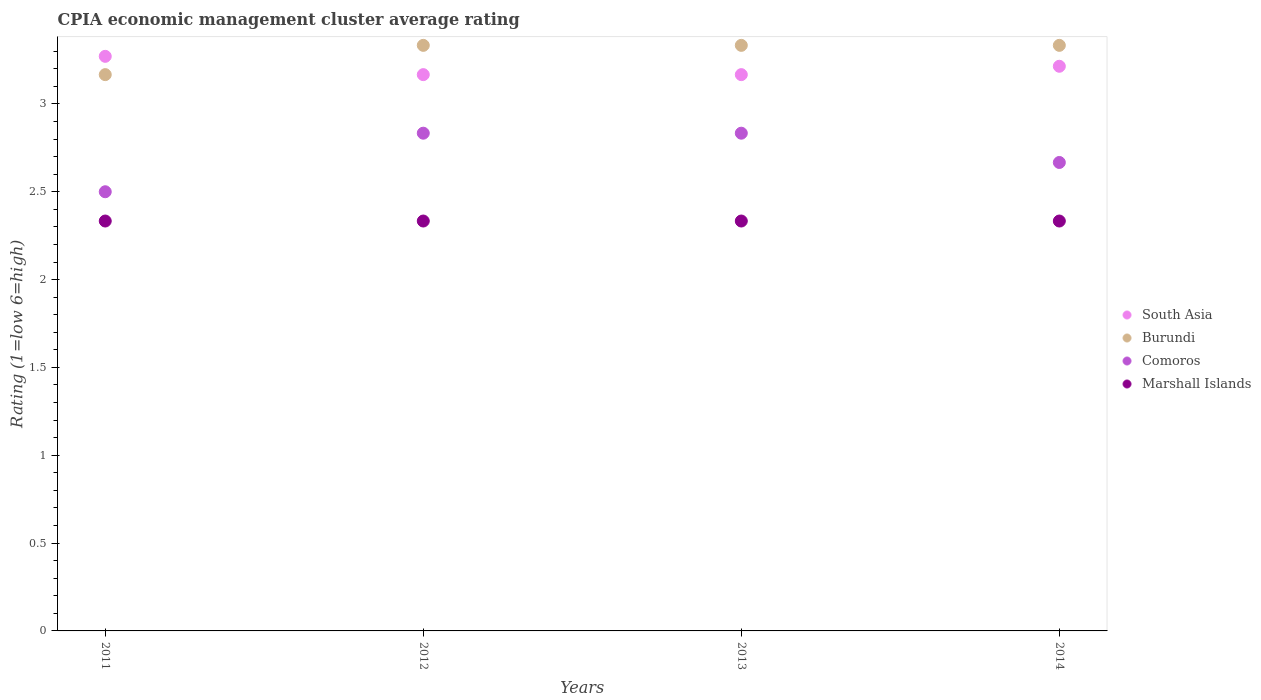Is the number of dotlines equal to the number of legend labels?
Give a very brief answer. Yes. What is the CPIA rating in Comoros in 2011?
Make the answer very short. 2.5. Across all years, what is the maximum CPIA rating in Burundi?
Give a very brief answer. 3.33. Across all years, what is the minimum CPIA rating in Burundi?
Provide a succinct answer. 3.17. In which year was the CPIA rating in Burundi maximum?
Your answer should be compact. 2012. What is the total CPIA rating in Comoros in the graph?
Your answer should be very brief. 10.83. What is the difference between the CPIA rating in Comoros in 2013 and that in 2014?
Ensure brevity in your answer.  0.17. What is the difference between the CPIA rating in Comoros in 2011 and the CPIA rating in Marshall Islands in 2013?
Keep it short and to the point. 0.17. What is the average CPIA rating in Marshall Islands per year?
Your response must be concise. 2.33. In how many years, is the CPIA rating in South Asia greater than 1.3?
Offer a terse response. 4. What is the ratio of the CPIA rating in Marshall Islands in 2012 to that in 2014?
Your answer should be compact. 1. Is the CPIA rating in South Asia in 2012 less than that in 2014?
Ensure brevity in your answer.  Yes. Is the difference between the CPIA rating in Burundi in 2011 and 2014 greater than the difference between the CPIA rating in Comoros in 2011 and 2014?
Give a very brief answer. Yes. What is the difference between the highest and the lowest CPIA rating in South Asia?
Ensure brevity in your answer.  0.1. Is the sum of the CPIA rating in Burundi in 2011 and 2013 greater than the maximum CPIA rating in Marshall Islands across all years?
Provide a succinct answer. Yes. Is it the case that in every year, the sum of the CPIA rating in Burundi and CPIA rating in Comoros  is greater than the sum of CPIA rating in Marshall Islands and CPIA rating in South Asia?
Make the answer very short. Yes. Does the CPIA rating in South Asia monotonically increase over the years?
Your response must be concise. No. How many dotlines are there?
Your response must be concise. 4. Are the values on the major ticks of Y-axis written in scientific E-notation?
Ensure brevity in your answer.  No. Does the graph contain any zero values?
Your response must be concise. No. Does the graph contain grids?
Keep it short and to the point. No. Where does the legend appear in the graph?
Your response must be concise. Center right. How are the legend labels stacked?
Your answer should be compact. Vertical. What is the title of the graph?
Your answer should be very brief. CPIA economic management cluster average rating. What is the label or title of the Y-axis?
Offer a terse response. Rating (1=low 6=high). What is the Rating (1=low 6=high) of South Asia in 2011?
Your answer should be very brief. 3.27. What is the Rating (1=low 6=high) in Burundi in 2011?
Your answer should be very brief. 3.17. What is the Rating (1=low 6=high) of Comoros in 2011?
Give a very brief answer. 2.5. What is the Rating (1=low 6=high) of Marshall Islands in 2011?
Provide a succinct answer. 2.33. What is the Rating (1=low 6=high) in South Asia in 2012?
Give a very brief answer. 3.17. What is the Rating (1=low 6=high) of Burundi in 2012?
Make the answer very short. 3.33. What is the Rating (1=low 6=high) in Comoros in 2012?
Your answer should be compact. 2.83. What is the Rating (1=low 6=high) in Marshall Islands in 2012?
Offer a terse response. 2.33. What is the Rating (1=low 6=high) in South Asia in 2013?
Your response must be concise. 3.17. What is the Rating (1=low 6=high) of Burundi in 2013?
Offer a terse response. 3.33. What is the Rating (1=low 6=high) of Comoros in 2013?
Ensure brevity in your answer.  2.83. What is the Rating (1=low 6=high) of Marshall Islands in 2013?
Offer a terse response. 2.33. What is the Rating (1=low 6=high) in South Asia in 2014?
Offer a terse response. 3.21. What is the Rating (1=low 6=high) of Burundi in 2014?
Ensure brevity in your answer.  3.33. What is the Rating (1=low 6=high) of Comoros in 2014?
Offer a terse response. 2.67. What is the Rating (1=low 6=high) of Marshall Islands in 2014?
Ensure brevity in your answer.  2.33. Across all years, what is the maximum Rating (1=low 6=high) in South Asia?
Provide a short and direct response. 3.27. Across all years, what is the maximum Rating (1=low 6=high) of Burundi?
Make the answer very short. 3.33. Across all years, what is the maximum Rating (1=low 6=high) of Comoros?
Offer a terse response. 2.83. Across all years, what is the maximum Rating (1=low 6=high) of Marshall Islands?
Keep it short and to the point. 2.33. Across all years, what is the minimum Rating (1=low 6=high) in South Asia?
Your response must be concise. 3.17. Across all years, what is the minimum Rating (1=low 6=high) in Burundi?
Make the answer very short. 3.17. Across all years, what is the minimum Rating (1=low 6=high) of Marshall Islands?
Provide a short and direct response. 2.33. What is the total Rating (1=low 6=high) in South Asia in the graph?
Your response must be concise. 12.82. What is the total Rating (1=low 6=high) of Burundi in the graph?
Offer a very short reply. 13.17. What is the total Rating (1=low 6=high) of Comoros in the graph?
Your answer should be very brief. 10.83. What is the total Rating (1=low 6=high) in Marshall Islands in the graph?
Make the answer very short. 9.33. What is the difference between the Rating (1=low 6=high) in South Asia in 2011 and that in 2012?
Provide a succinct answer. 0.1. What is the difference between the Rating (1=low 6=high) of Burundi in 2011 and that in 2012?
Provide a succinct answer. -0.17. What is the difference between the Rating (1=low 6=high) of Comoros in 2011 and that in 2012?
Your answer should be compact. -0.33. What is the difference between the Rating (1=low 6=high) in South Asia in 2011 and that in 2013?
Give a very brief answer. 0.1. What is the difference between the Rating (1=low 6=high) of Marshall Islands in 2011 and that in 2013?
Provide a succinct answer. 0. What is the difference between the Rating (1=low 6=high) of South Asia in 2011 and that in 2014?
Your answer should be very brief. 0.06. What is the difference between the Rating (1=low 6=high) of Comoros in 2012 and that in 2013?
Offer a very short reply. 0. What is the difference between the Rating (1=low 6=high) of Marshall Islands in 2012 and that in 2013?
Keep it short and to the point. 0. What is the difference between the Rating (1=low 6=high) of South Asia in 2012 and that in 2014?
Provide a succinct answer. -0.05. What is the difference between the Rating (1=low 6=high) in Comoros in 2012 and that in 2014?
Offer a terse response. 0.17. What is the difference between the Rating (1=low 6=high) in South Asia in 2013 and that in 2014?
Ensure brevity in your answer.  -0.05. What is the difference between the Rating (1=low 6=high) of Burundi in 2013 and that in 2014?
Keep it short and to the point. 0. What is the difference between the Rating (1=low 6=high) of Comoros in 2013 and that in 2014?
Your response must be concise. 0.17. What is the difference between the Rating (1=low 6=high) of South Asia in 2011 and the Rating (1=low 6=high) of Burundi in 2012?
Provide a succinct answer. -0.06. What is the difference between the Rating (1=low 6=high) of South Asia in 2011 and the Rating (1=low 6=high) of Comoros in 2012?
Your answer should be very brief. 0.44. What is the difference between the Rating (1=low 6=high) in South Asia in 2011 and the Rating (1=low 6=high) in Marshall Islands in 2012?
Provide a short and direct response. 0.94. What is the difference between the Rating (1=low 6=high) of Burundi in 2011 and the Rating (1=low 6=high) of Comoros in 2012?
Provide a succinct answer. 0.33. What is the difference between the Rating (1=low 6=high) in South Asia in 2011 and the Rating (1=low 6=high) in Burundi in 2013?
Ensure brevity in your answer.  -0.06. What is the difference between the Rating (1=low 6=high) of South Asia in 2011 and the Rating (1=low 6=high) of Comoros in 2013?
Give a very brief answer. 0.44. What is the difference between the Rating (1=low 6=high) of Burundi in 2011 and the Rating (1=low 6=high) of Marshall Islands in 2013?
Your answer should be very brief. 0.83. What is the difference between the Rating (1=low 6=high) of South Asia in 2011 and the Rating (1=low 6=high) of Burundi in 2014?
Provide a short and direct response. -0.06. What is the difference between the Rating (1=low 6=high) in South Asia in 2011 and the Rating (1=low 6=high) in Comoros in 2014?
Your response must be concise. 0.6. What is the difference between the Rating (1=low 6=high) of South Asia in 2011 and the Rating (1=low 6=high) of Marshall Islands in 2014?
Your answer should be compact. 0.94. What is the difference between the Rating (1=low 6=high) of Burundi in 2011 and the Rating (1=low 6=high) of Comoros in 2014?
Provide a short and direct response. 0.5. What is the difference between the Rating (1=low 6=high) in South Asia in 2012 and the Rating (1=low 6=high) in Burundi in 2013?
Offer a terse response. -0.17. What is the difference between the Rating (1=low 6=high) in South Asia in 2012 and the Rating (1=low 6=high) in Comoros in 2013?
Keep it short and to the point. 0.33. What is the difference between the Rating (1=low 6=high) of South Asia in 2012 and the Rating (1=low 6=high) of Marshall Islands in 2013?
Make the answer very short. 0.83. What is the difference between the Rating (1=low 6=high) in Burundi in 2012 and the Rating (1=low 6=high) in Comoros in 2013?
Give a very brief answer. 0.5. What is the difference between the Rating (1=low 6=high) in Comoros in 2012 and the Rating (1=low 6=high) in Marshall Islands in 2013?
Give a very brief answer. 0.5. What is the difference between the Rating (1=low 6=high) in South Asia in 2012 and the Rating (1=low 6=high) in Comoros in 2014?
Offer a very short reply. 0.5. What is the difference between the Rating (1=low 6=high) in Burundi in 2012 and the Rating (1=low 6=high) in Comoros in 2014?
Your answer should be compact. 0.67. What is the difference between the Rating (1=low 6=high) of South Asia in 2013 and the Rating (1=low 6=high) of Burundi in 2014?
Your response must be concise. -0.17. What is the difference between the Rating (1=low 6=high) in South Asia in 2013 and the Rating (1=low 6=high) in Comoros in 2014?
Your response must be concise. 0.5. What is the difference between the Rating (1=low 6=high) in South Asia in 2013 and the Rating (1=low 6=high) in Marshall Islands in 2014?
Offer a terse response. 0.83. What is the difference between the Rating (1=low 6=high) of Burundi in 2013 and the Rating (1=low 6=high) of Marshall Islands in 2014?
Keep it short and to the point. 1. What is the average Rating (1=low 6=high) of South Asia per year?
Your response must be concise. 3.2. What is the average Rating (1=low 6=high) of Burundi per year?
Give a very brief answer. 3.29. What is the average Rating (1=low 6=high) of Comoros per year?
Ensure brevity in your answer.  2.71. What is the average Rating (1=low 6=high) in Marshall Islands per year?
Make the answer very short. 2.33. In the year 2011, what is the difference between the Rating (1=low 6=high) of South Asia and Rating (1=low 6=high) of Burundi?
Provide a short and direct response. 0.1. In the year 2011, what is the difference between the Rating (1=low 6=high) of South Asia and Rating (1=low 6=high) of Comoros?
Your answer should be very brief. 0.77. In the year 2011, what is the difference between the Rating (1=low 6=high) in Burundi and Rating (1=low 6=high) in Comoros?
Provide a succinct answer. 0.67. In the year 2011, what is the difference between the Rating (1=low 6=high) in Comoros and Rating (1=low 6=high) in Marshall Islands?
Keep it short and to the point. 0.17. In the year 2012, what is the difference between the Rating (1=low 6=high) in South Asia and Rating (1=low 6=high) in Burundi?
Provide a succinct answer. -0.17. In the year 2012, what is the difference between the Rating (1=low 6=high) of South Asia and Rating (1=low 6=high) of Comoros?
Ensure brevity in your answer.  0.33. In the year 2012, what is the difference between the Rating (1=low 6=high) in Burundi and Rating (1=low 6=high) in Comoros?
Your answer should be compact. 0.5. In the year 2012, what is the difference between the Rating (1=low 6=high) in Burundi and Rating (1=low 6=high) in Marshall Islands?
Make the answer very short. 1. In the year 2012, what is the difference between the Rating (1=low 6=high) of Comoros and Rating (1=low 6=high) of Marshall Islands?
Make the answer very short. 0.5. In the year 2013, what is the difference between the Rating (1=low 6=high) of Comoros and Rating (1=low 6=high) of Marshall Islands?
Keep it short and to the point. 0.5. In the year 2014, what is the difference between the Rating (1=low 6=high) in South Asia and Rating (1=low 6=high) in Burundi?
Make the answer very short. -0.12. In the year 2014, what is the difference between the Rating (1=low 6=high) in South Asia and Rating (1=low 6=high) in Comoros?
Provide a short and direct response. 0.55. In the year 2014, what is the difference between the Rating (1=low 6=high) in South Asia and Rating (1=low 6=high) in Marshall Islands?
Provide a succinct answer. 0.88. In the year 2014, what is the difference between the Rating (1=low 6=high) in Burundi and Rating (1=low 6=high) in Comoros?
Provide a short and direct response. 0.67. In the year 2014, what is the difference between the Rating (1=low 6=high) of Burundi and Rating (1=low 6=high) of Marshall Islands?
Give a very brief answer. 1. What is the ratio of the Rating (1=low 6=high) in South Asia in 2011 to that in 2012?
Offer a terse response. 1.03. What is the ratio of the Rating (1=low 6=high) in Burundi in 2011 to that in 2012?
Your response must be concise. 0.95. What is the ratio of the Rating (1=low 6=high) of Comoros in 2011 to that in 2012?
Your response must be concise. 0.88. What is the ratio of the Rating (1=low 6=high) of Marshall Islands in 2011 to that in 2012?
Provide a short and direct response. 1. What is the ratio of the Rating (1=low 6=high) of South Asia in 2011 to that in 2013?
Provide a succinct answer. 1.03. What is the ratio of the Rating (1=low 6=high) in Comoros in 2011 to that in 2013?
Your response must be concise. 0.88. What is the ratio of the Rating (1=low 6=high) in Marshall Islands in 2011 to that in 2013?
Provide a succinct answer. 1. What is the ratio of the Rating (1=low 6=high) in South Asia in 2011 to that in 2014?
Your response must be concise. 1.02. What is the ratio of the Rating (1=low 6=high) in Comoros in 2011 to that in 2014?
Make the answer very short. 0.94. What is the ratio of the Rating (1=low 6=high) of South Asia in 2012 to that in 2014?
Provide a short and direct response. 0.99. What is the ratio of the Rating (1=low 6=high) of Comoros in 2012 to that in 2014?
Your answer should be compact. 1.06. What is the ratio of the Rating (1=low 6=high) in Marshall Islands in 2012 to that in 2014?
Your answer should be compact. 1. What is the ratio of the Rating (1=low 6=high) in South Asia in 2013 to that in 2014?
Offer a very short reply. 0.99. What is the ratio of the Rating (1=low 6=high) in Comoros in 2013 to that in 2014?
Provide a succinct answer. 1.06. What is the difference between the highest and the second highest Rating (1=low 6=high) in South Asia?
Keep it short and to the point. 0.06. What is the difference between the highest and the second highest Rating (1=low 6=high) of Comoros?
Keep it short and to the point. 0. What is the difference between the highest and the second highest Rating (1=low 6=high) of Marshall Islands?
Keep it short and to the point. 0. What is the difference between the highest and the lowest Rating (1=low 6=high) in South Asia?
Give a very brief answer. 0.1. What is the difference between the highest and the lowest Rating (1=low 6=high) in Burundi?
Ensure brevity in your answer.  0.17. What is the difference between the highest and the lowest Rating (1=low 6=high) of Comoros?
Make the answer very short. 0.33. What is the difference between the highest and the lowest Rating (1=low 6=high) of Marshall Islands?
Your answer should be very brief. 0. 